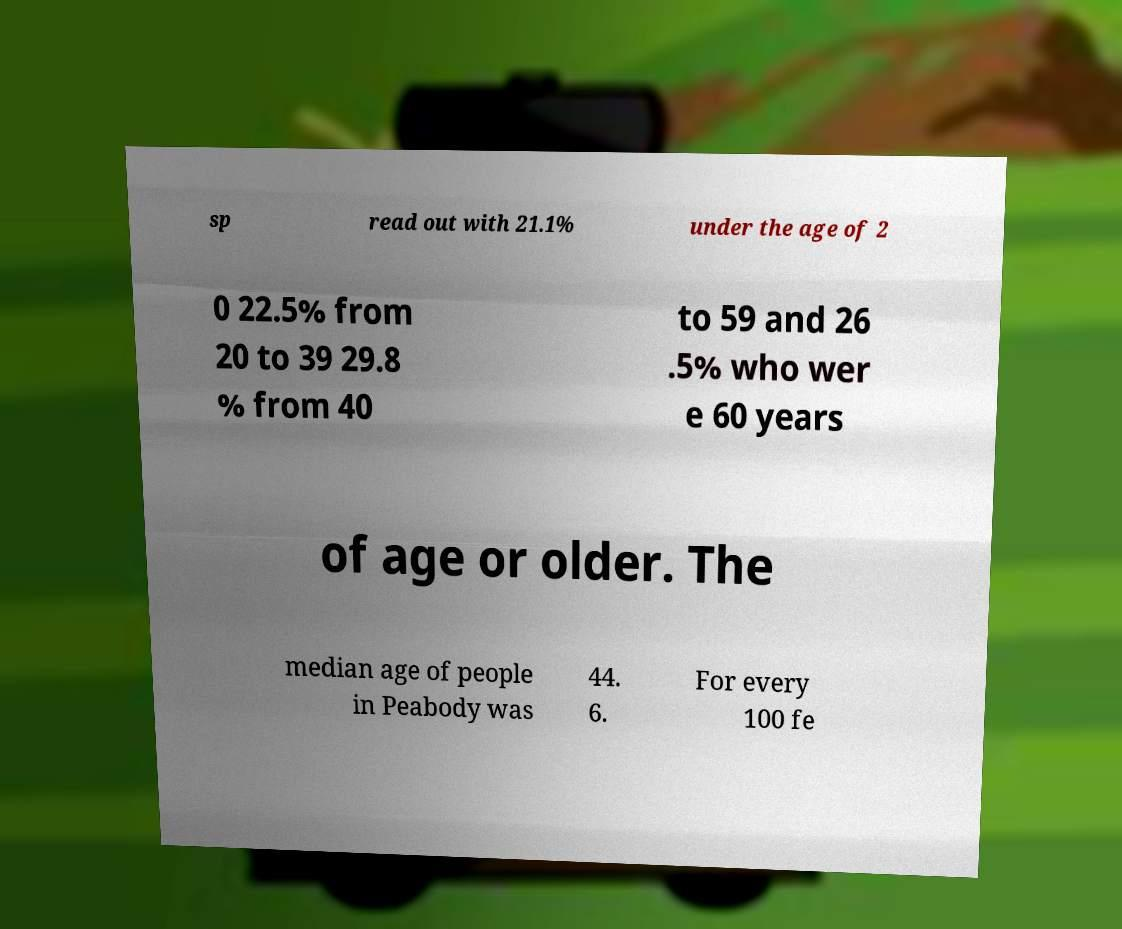Can you accurately transcribe the text from the provided image for me? sp read out with 21.1% under the age of 2 0 22.5% from 20 to 39 29.8 % from 40 to 59 and 26 .5% who wer e 60 years of age or older. The median age of people in Peabody was 44. 6. For every 100 fe 